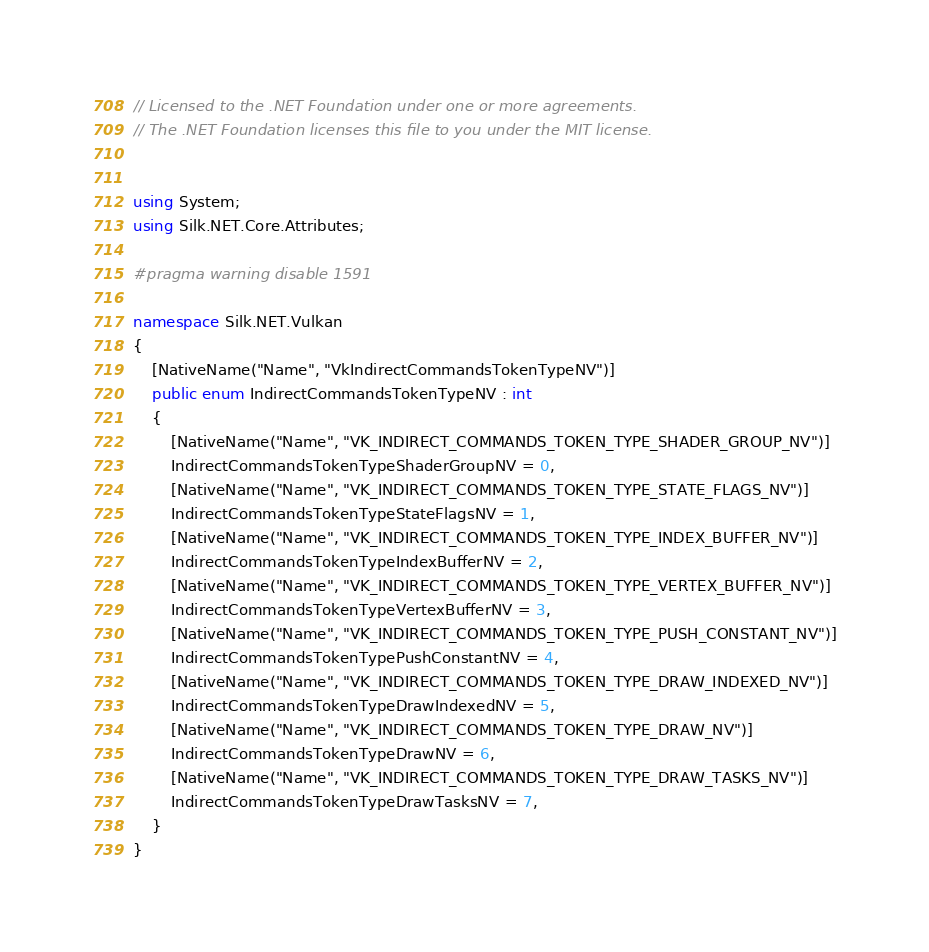<code> <loc_0><loc_0><loc_500><loc_500><_C#_>// Licensed to the .NET Foundation under one or more agreements.
// The .NET Foundation licenses this file to you under the MIT license.


using System;
using Silk.NET.Core.Attributes;

#pragma warning disable 1591

namespace Silk.NET.Vulkan
{
    [NativeName("Name", "VkIndirectCommandsTokenTypeNV")]
    public enum IndirectCommandsTokenTypeNV : int
    {
        [NativeName("Name", "VK_INDIRECT_COMMANDS_TOKEN_TYPE_SHADER_GROUP_NV")]
        IndirectCommandsTokenTypeShaderGroupNV = 0,
        [NativeName("Name", "VK_INDIRECT_COMMANDS_TOKEN_TYPE_STATE_FLAGS_NV")]
        IndirectCommandsTokenTypeStateFlagsNV = 1,
        [NativeName("Name", "VK_INDIRECT_COMMANDS_TOKEN_TYPE_INDEX_BUFFER_NV")]
        IndirectCommandsTokenTypeIndexBufferNV = 2,
        [NativeName("Name", "VK_INDIRECT_COMMANDS_TOKEN_TYPE_VERTEX_BUFFER_NV")]
        IndirectCommandsTokenTypeVertexBufferNV = 3,
        [NativeName("Name", "VK_INDIRECT_COMMANDS_TOKEN_TYPE_PUSH_CONSTANT_NV")]
        IndirectCommandsTokenTypePushConstantNV = 4,
        [NativeName("Name", "VK_INDIRECT_COMMANDS_TOKEN_TYPE_DRAW_INDEXED_NV")]
        IndirectCommandsTokenTypeDrawIndexedNV = 5,
        [NativeName("Name", "VK_INDIRECT_COMMANDS_TOKEN_TYPE_DRAW_NV")]
        IndirectCommandsTokenTypeDrawNV = 6,
        [NativeName("Name", "VK_INDIRECT_COMMANDS_TOKEN_TYPE_DRAW_TASKS_NV")]
        IndirectCommandsTokenTypeDrawTasksNV = 7,
    }
}
</code> 